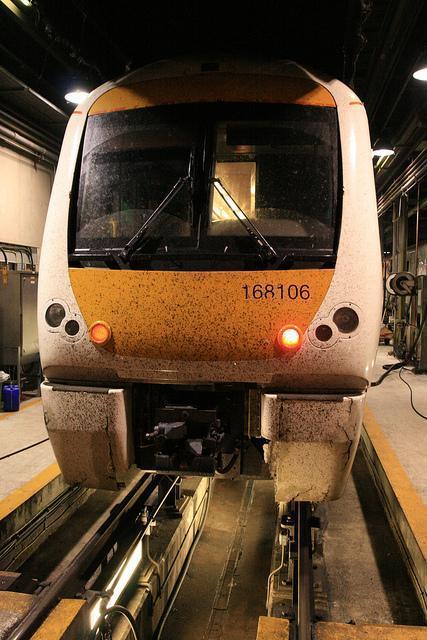How many trains are in the photo?
Give a very brief answer. 1. How many white dogs are there?
Give a very brief answer. 0. 